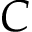Convert formula to latex. <formula><loc_0><loc_0><loc_500><loc_500>C</formula> 